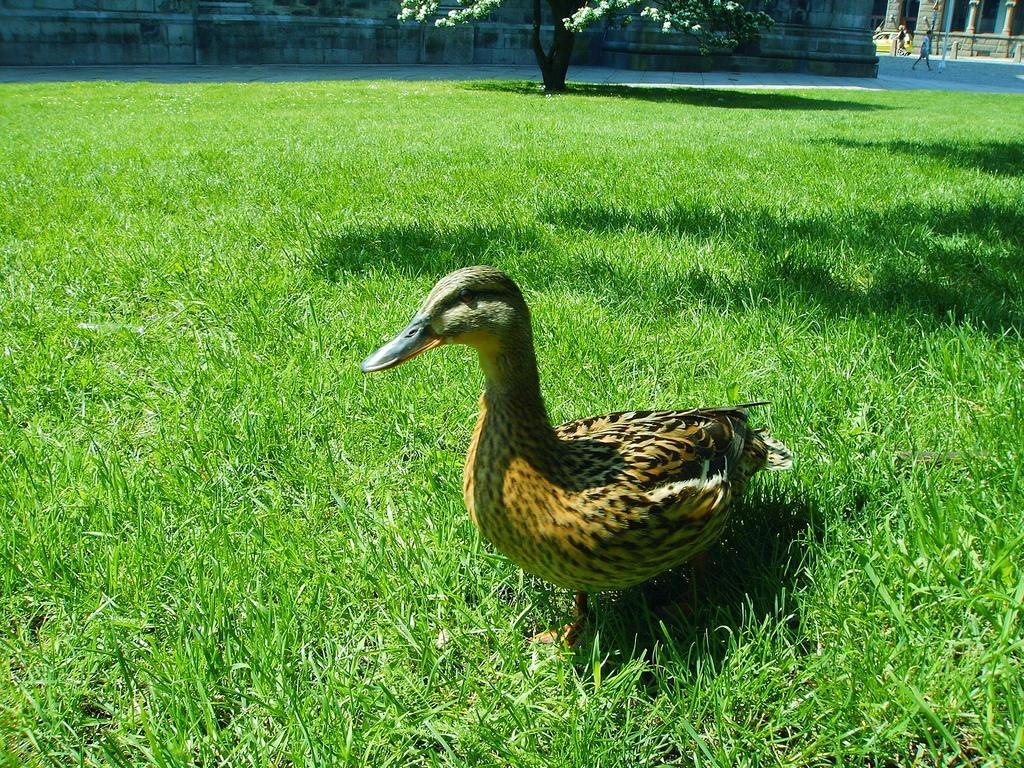How would you summarize this image in a sentence or two? We can see bird on the grass. In the background we can see people,pole and tree. 